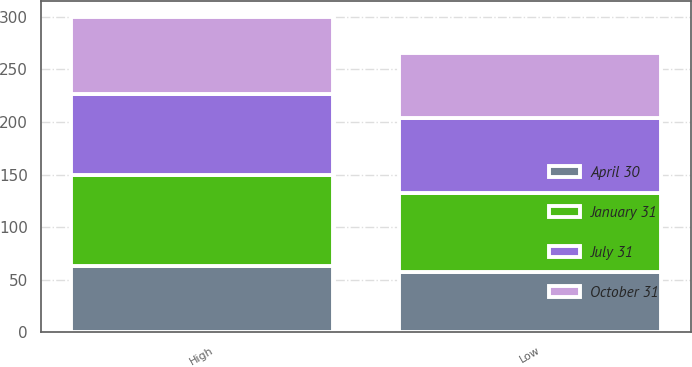Convert chart to OTSL. <chart><loc_0><loc_0><loc_500><loc_500><stacked_bar_chart><ecel><fcel>High<fcel>Low<nl><fcel>April 30<fcel>62.68<fcel>56.84<nl><fcel>October 31<fcel>73.85<fcel>62.62<nl><fcel>July 31<fcel>76.69<fcel>70.93<nl><fcel>January 31<fcel>87.19<fcel>75.65<nl></chart> 